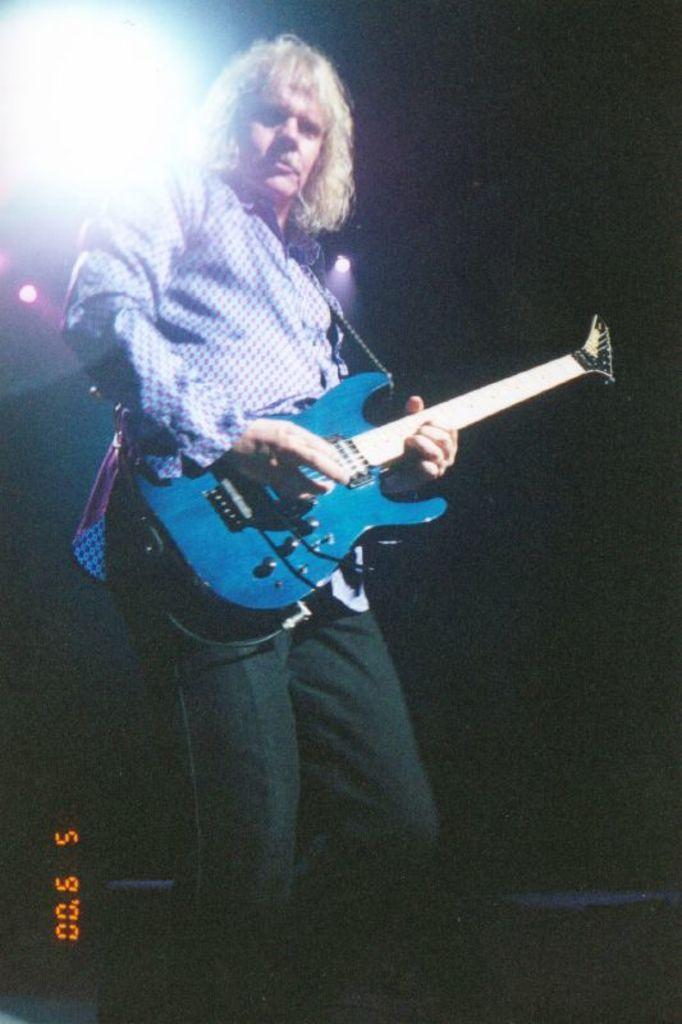Please provide a concise description of this image. Here a man is standing and playing guitar, on the left at the bottom there is a number displayed. 